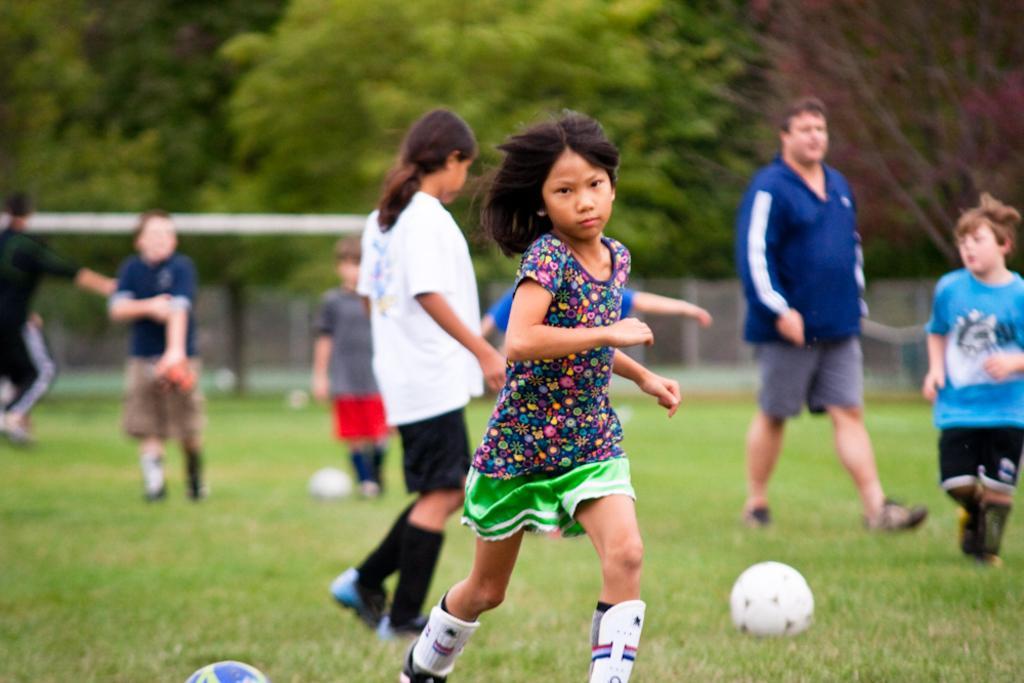Describe this image in one or two sentences. In this picture we can see group of people and balls on the grass, in the background we can see metal rod and few trees. 